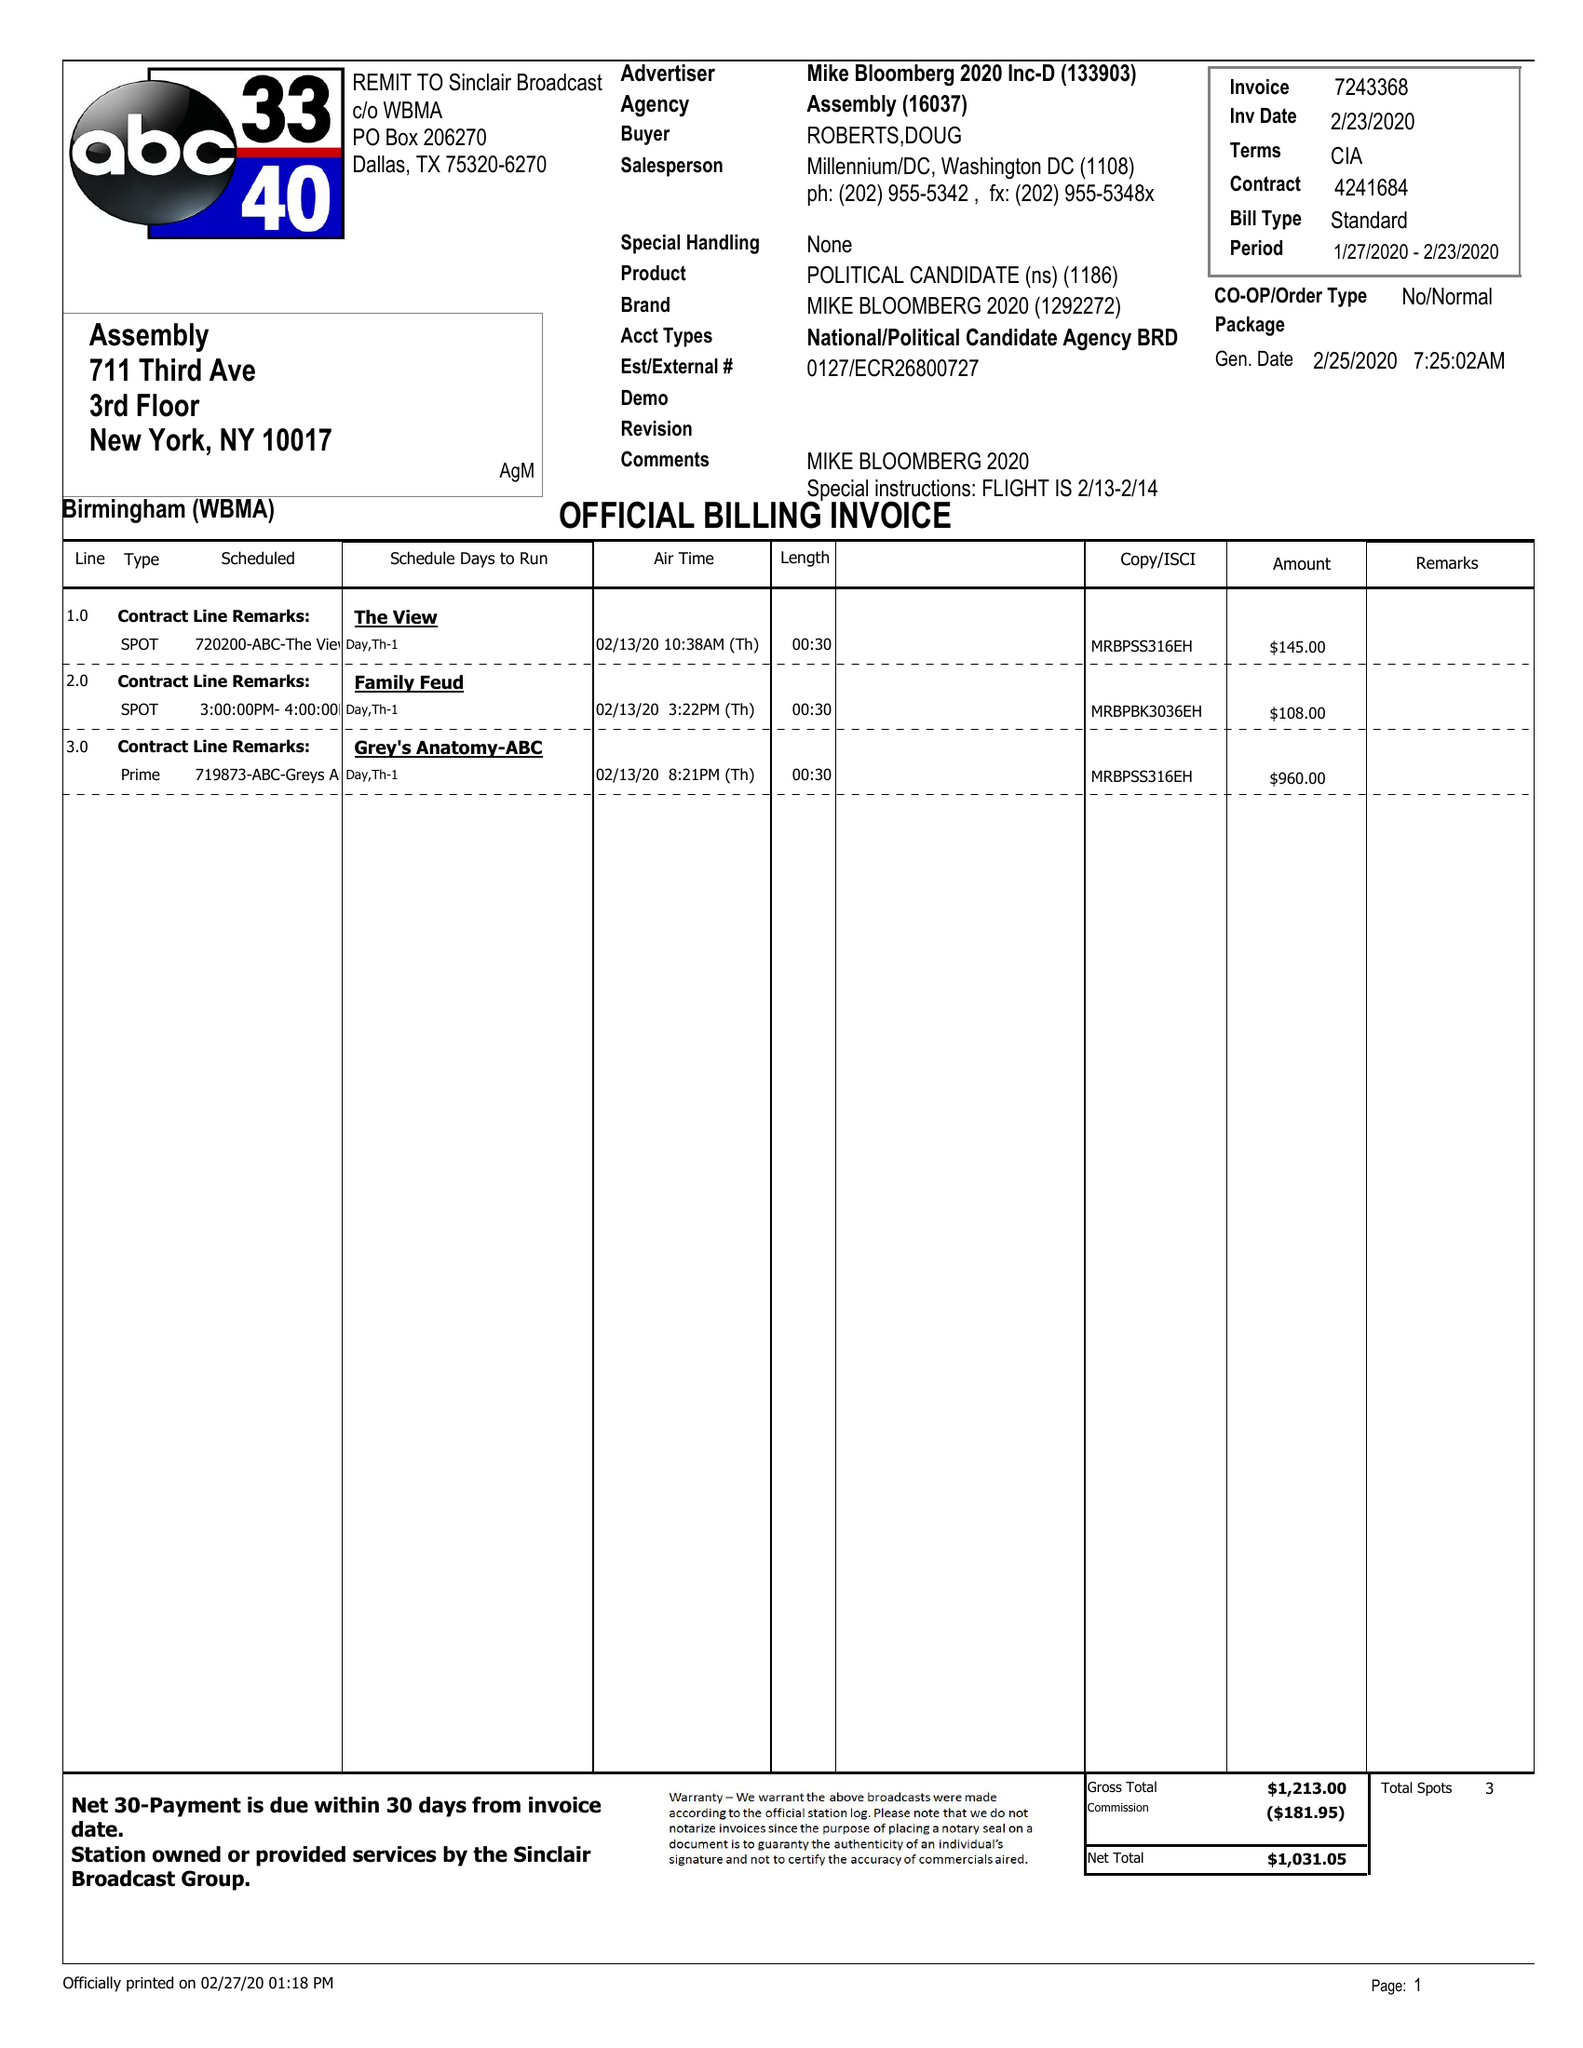What is the value for the gross_amount?
Answer the question using a single word or phrase. 1213.00 